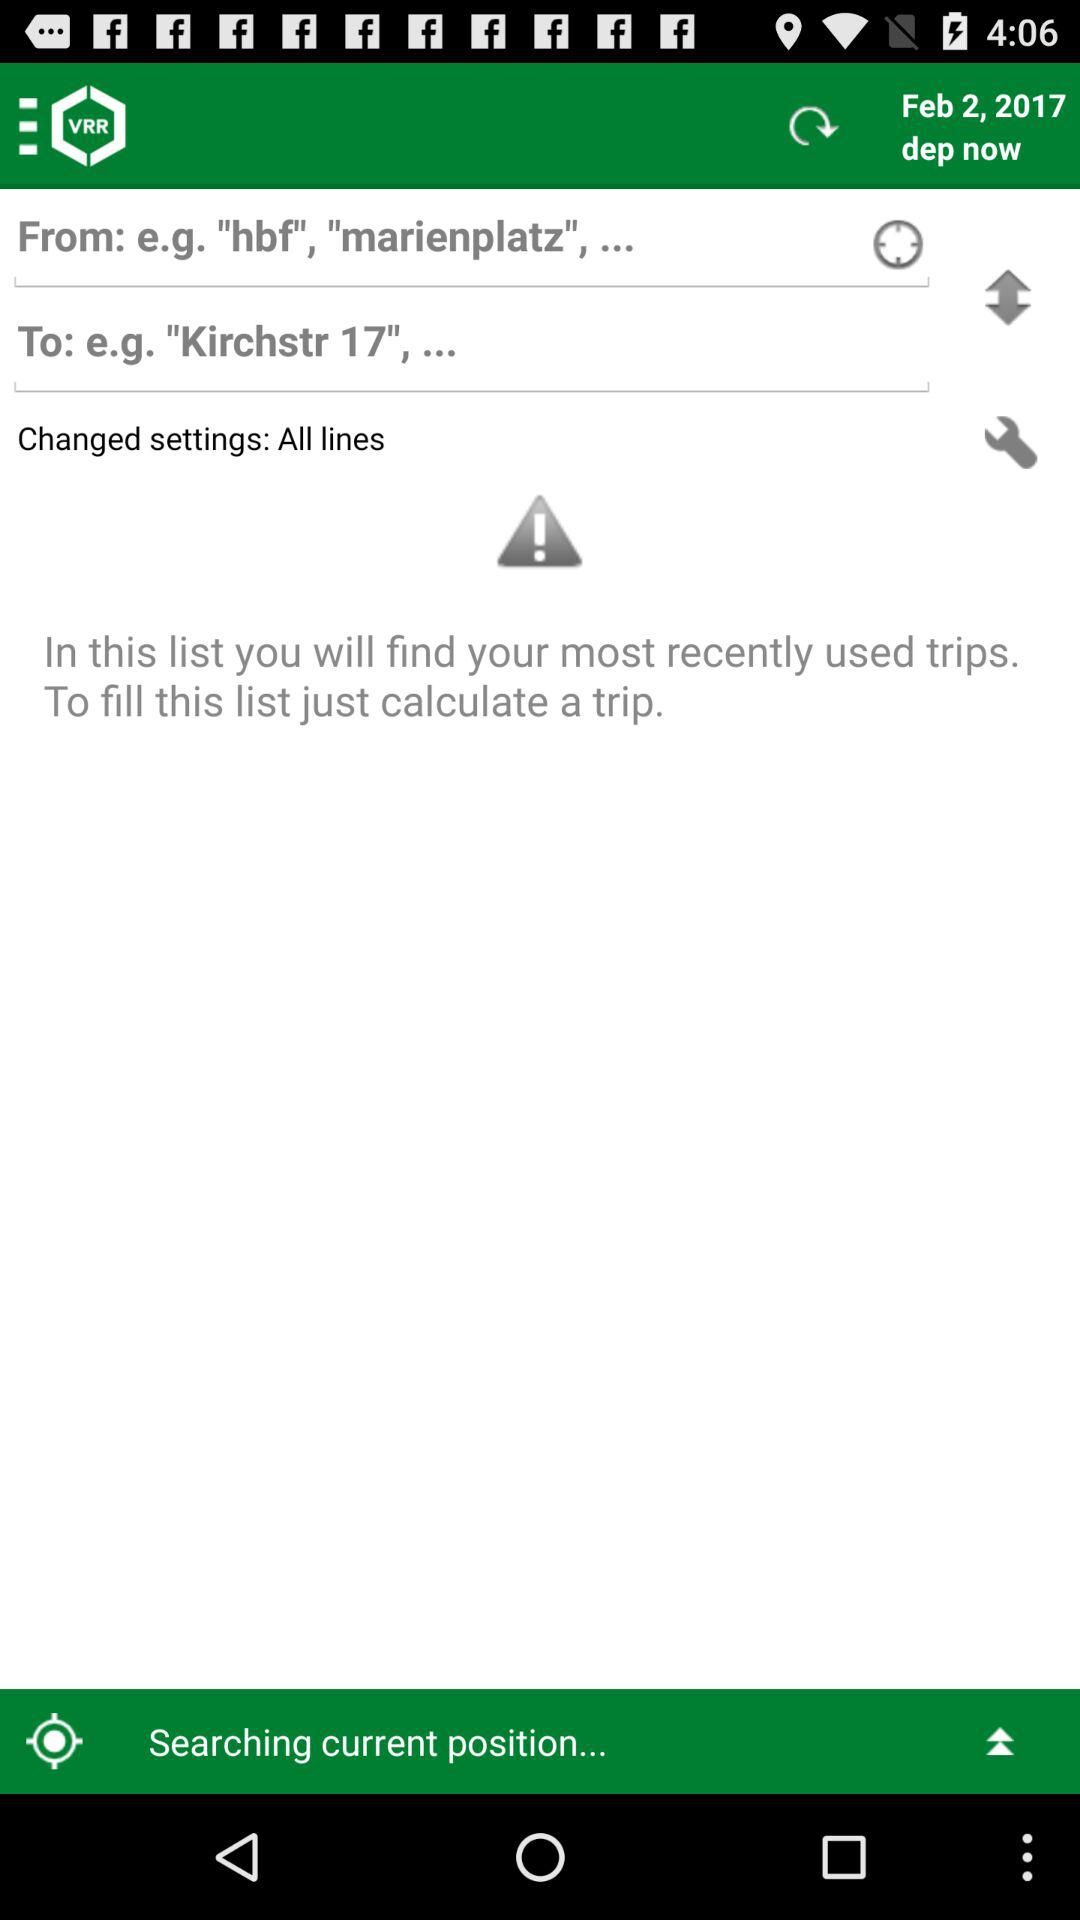How many text inputs are on the screen?
Answer the question using a single word or phrase. 2 